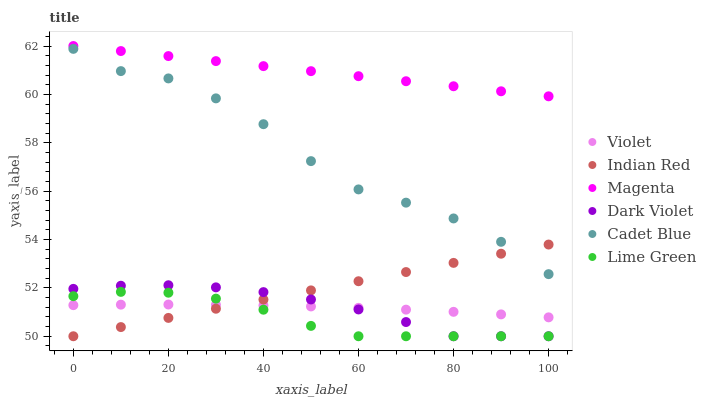Does Lime Green have the minimum area under the curve?
Answer yes or no. Yes. Does Magenta have the maximum area under the curve?
Answer yes or no. Yes. Does Dark Violet have the minimum area under the curve?
Answer yes or no. No. Does Dark Violet have the maximum area under the curve?
Answer yes or no. No. Is Indian Red the smoothest?
Answer yes or no. Yes. Is Cadet Blue the roughest?
Answer yes or no. Yes. Is Dark Violet the smoothest?
Answer yes or no. No. Is Dark Violet the roughest?
Answer yes or no. No. Does Dark Violet have the lowest value?
Answer yes or no. Yes. Does Violet have the lowest value?
Answer yes or no. No. Does Magenta have the highest value?
Answer yes or no. Yes. Does Dark Violet have the highest value?
Answer yes or no. No. Is Indian Red less than Magenta?
Answer yes or no. Yes. Is Cadet Blue greater than Violet?
Answer yes or no. Yes. Does Indian Red intersect Cadet Blue?
Answer yes or no. Yes. Is Indian Red less than Cadet Blue?
Answer yes or no. No. Is Indian Red greater than Cadet Blue?
Answer yes or no. No. Does Indian Red intersect Magenta?
Answer yes or no. No. 